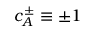Convert formula to latex. <formula><loc_0><loc_0><loc_500><loc_500>c _ { A } ^ { \pm } \equiv \pm 1</formula> 